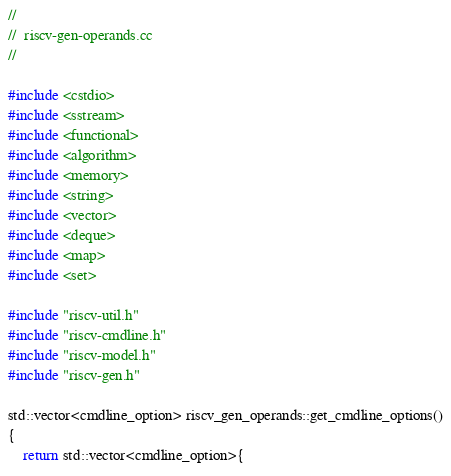Convert code to text. <code><loc_0><loc_0><loc_500><loc_500><_C++_>//
//  riscv-gen-operands.cc
//

#include <cstdio>
#include <sstream>
#include <functional>
#include <algorithm>
#include <memory>
#include <string>
#include <vector>
#include <deque>
#include <map>
#include <set>

#include "riscv-util.h"
#include "riscv-cmdline.h"
#include "riscv-model.h"
#include "riscv-gen.h"

std::vector<cmdline_option> riscv_gen_operands::get_cmdline_options()
{
	return std::vector<cmdline_option>{</code> 